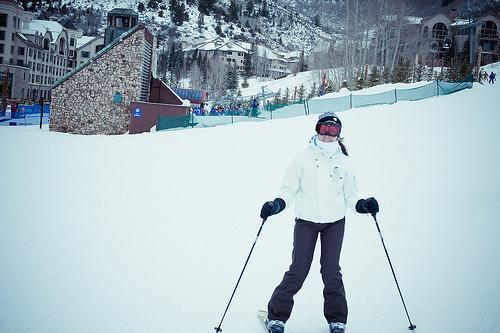How many people are there?
Give a very brief answer. 1. 